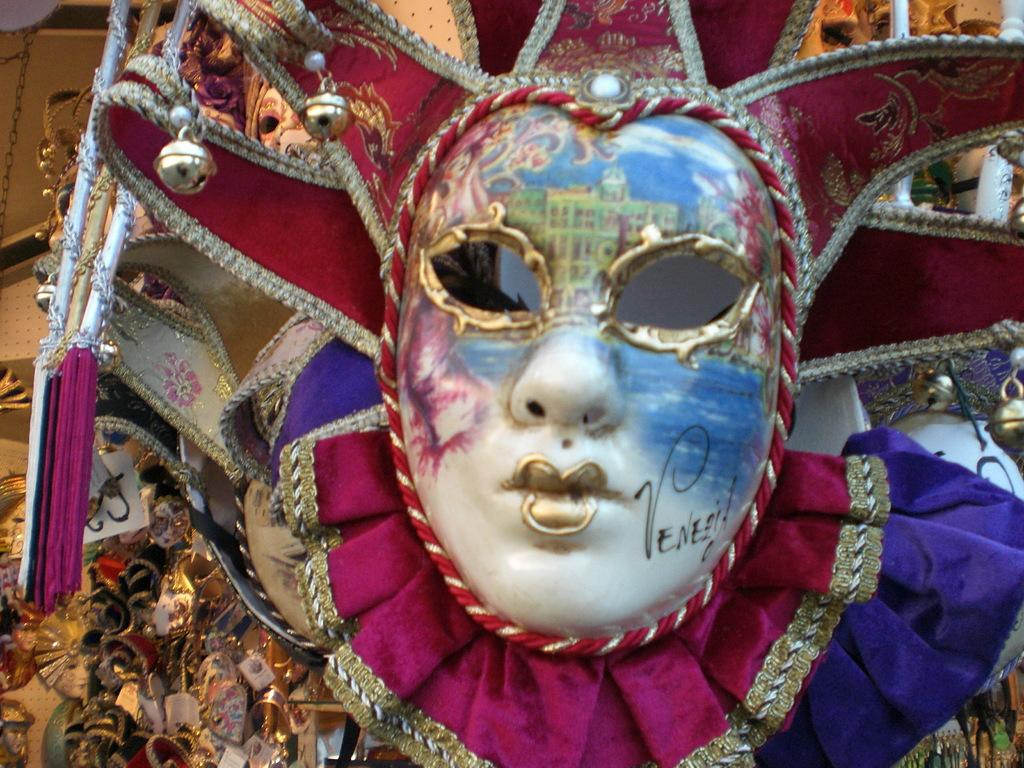What can be seen in the image that covers the face? There is a mask in the image. What is written on the mask? There is writing on the mask. What is visible behind the mask? There are objects behind the mask. Where is the chain located in the image? There is a chain in the top left corner of the image. What type of lamp does the father use to read the worm's story in the image? There is no lamp, father, or worm present in the image. 